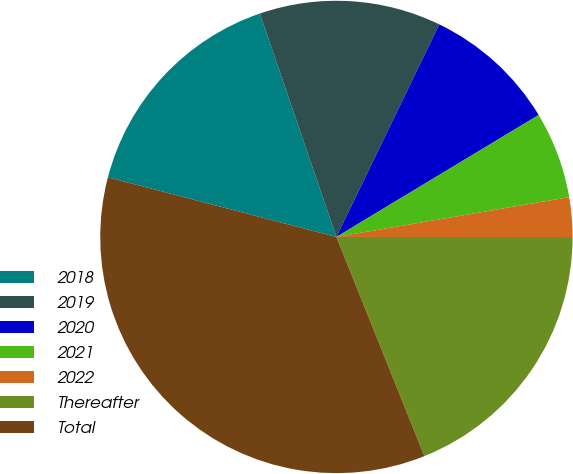<chart> <loc_0><loc_0><loc_500><loc_500><pie_chart><fcel>2018<fcel>2019<fcel>2020<fcel>2021<fcel>2022<fcel>Thereafter<fcel>Total<nl><fcel>15.68%<fcel>12.43%<fcel>9.19%<fcel>5.94%<fcel>2.7%<fcel>18.92%<fcel>35.14%<nl></chart> 